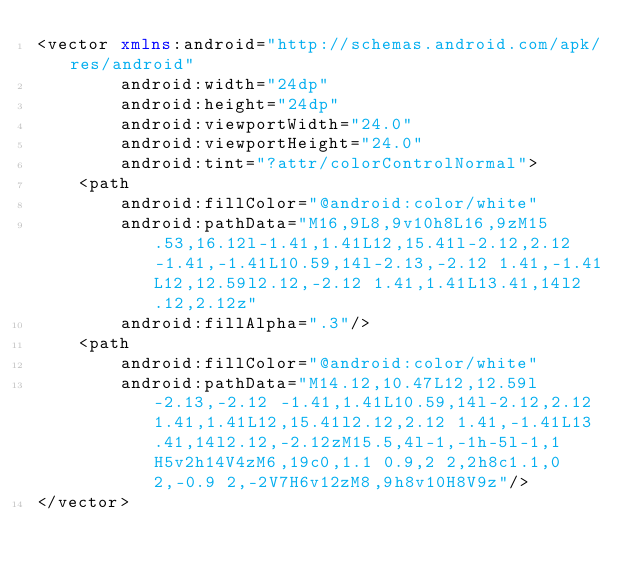Convert code to text. <code><loc_0><loc_0><loc_500><loc_500><_XML_><vector xmlns:android="http://schemas.android.com/apk/res/android"
        android:width="24dp"
        android:height="24dp"
        android:viewportWidth="24.0"
        android:viewportHeight="24.0"
        android:tint="?attr/colorControlNormal">
    <path
        android:fillColor="@android:color/white"
        android:pathData="M16,9L8,9v10h8L16,9zM15.53,16.12l-1.41,1.41L12,15.41l-2.12,2.12 -1.41,-1.41L10.59,14l-2.13,-2.12 1.41,-1.41L12,12.59l2.12,-2.12 1.41,1.41L13.41,14l2.12,2.12z"
        android:fillAlpha=".3"/>
    <path
        android:fillColor="@android:color/white"
        android:pathData="M14.12,10.47L12,12.59l-2.13,-2.12 -1.41,1.41L10.59,14l-2.12,2.12 1.41,1.41L12,15.41l2.12,2.12 1.41,-1.41L13.41,14l2.12,-2.12zM15.5,4l-1,-1h-5l-1,1H5v2h14V4zM6,19c0,1.1 0.9,2 2,2h8c1.1,0 2,-0.9 2,-2V7H6v12zM8,9h8v10H8V9z"/>
</vector>
</code> 